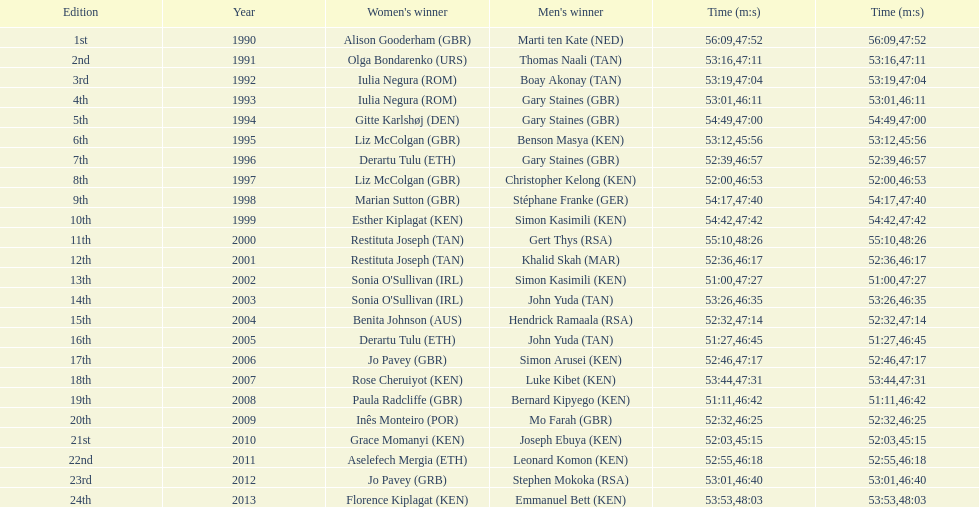Where any women faster than any men? No. 